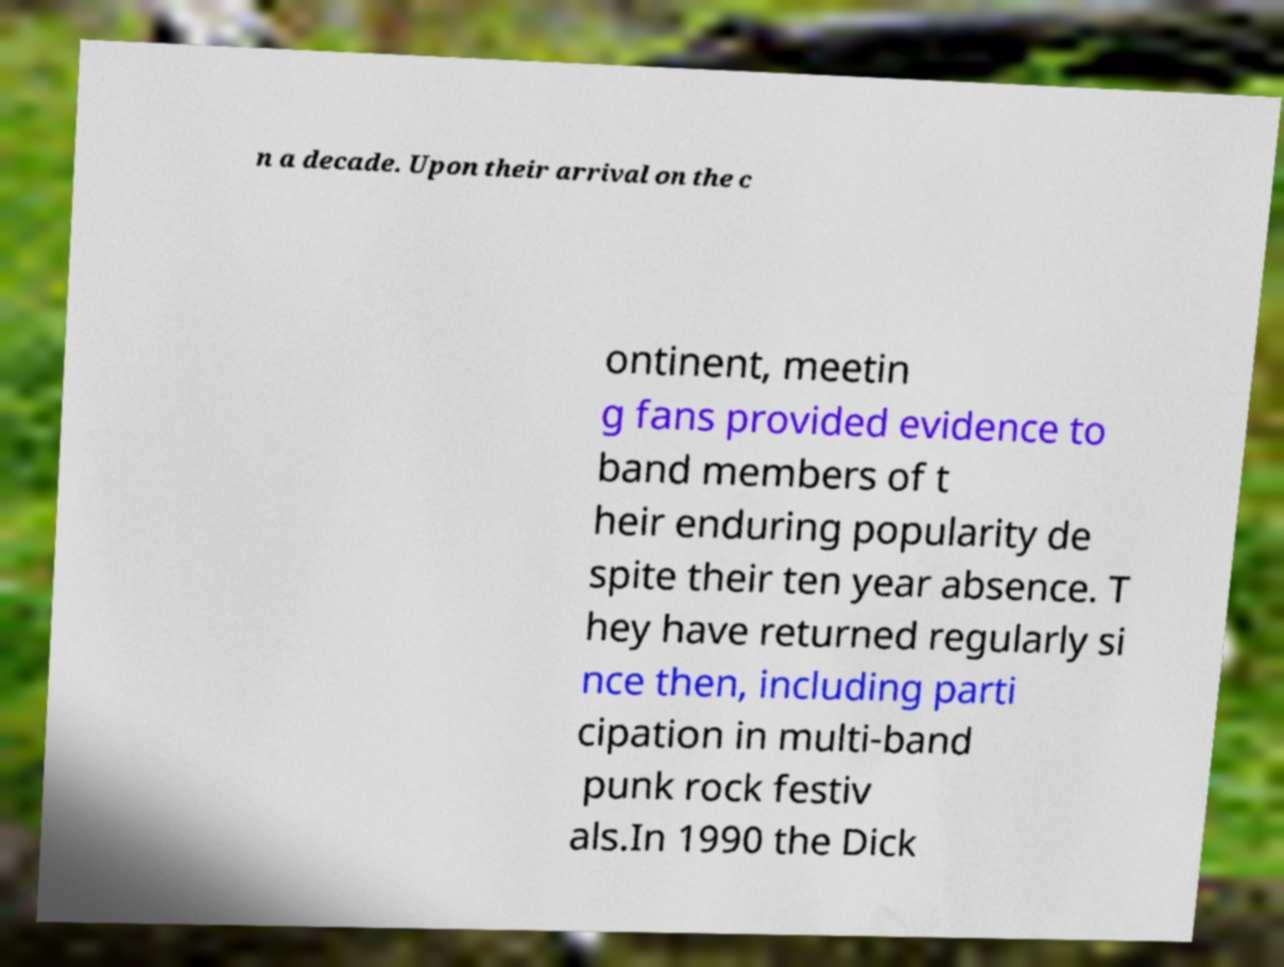Please read and relay the text visible in this image. What does it say? n a decade. Upon their arrival on the c ontinent, meetin g fans provided evidence to band members of t heir enduring popularity de spite their ten year absence. T hey have returned regularly si nce then, including parti cipation in multi-band punk rock festiv als.In 1990 the Dick 